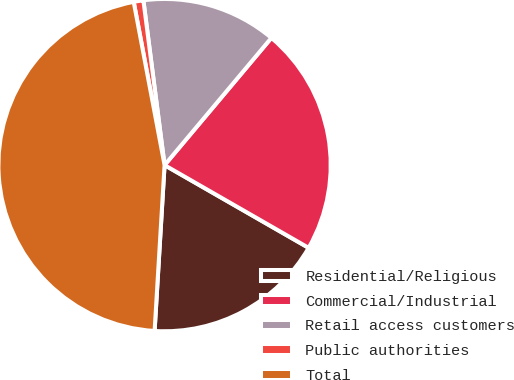<chart> <loc_0><loc_0><loc_500><loc_500><pie_chart><fcel>Residential/Religious<fcel>Commercial/Industrial<fcel>Retail access customers<fcel>Public authorities<fcel>Total<nl><fcel>17.66%<fcel>22.18%<fcel>13.15%<fcel>0.94%<fcel>46.07%<nl></chart> 